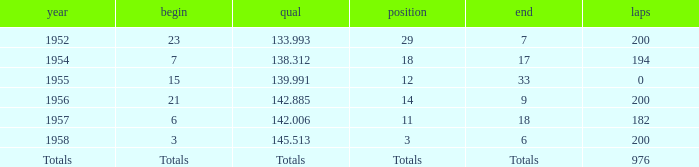What place did Jimmy Reece finish in 1957? 18.0. 